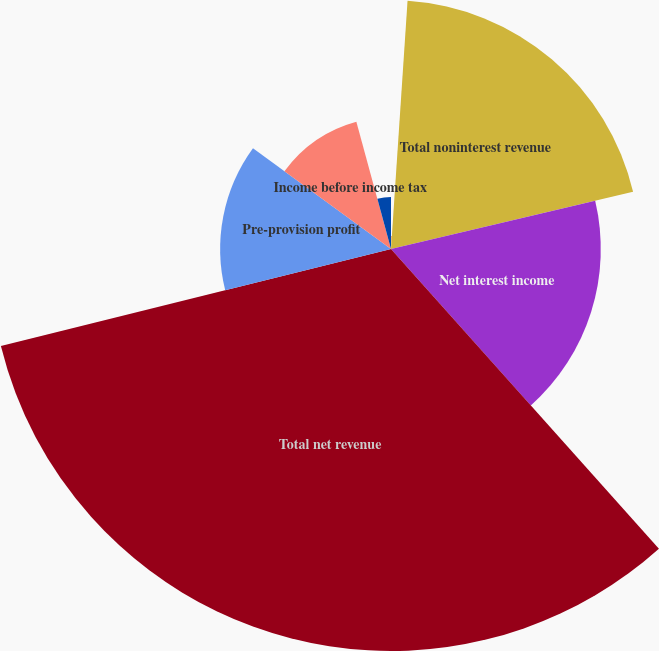<chart> <loc_0><loc_0><loc_500><loc_500><pie_chart><fcel>Other income<fcel>Total noninterest revenue<fcel>Net interest income<fcel>Total net revenue<fcel>Pre-provision profit<fcel>Income before income tax<fcel>Income tax expense<nl><fcel>1.06%<fcel>20.25%<fcel>17.08%<fcel>32.73%<fcel>13.91%<fcel>10.74%<fcel>4.23%<nl></chart> 